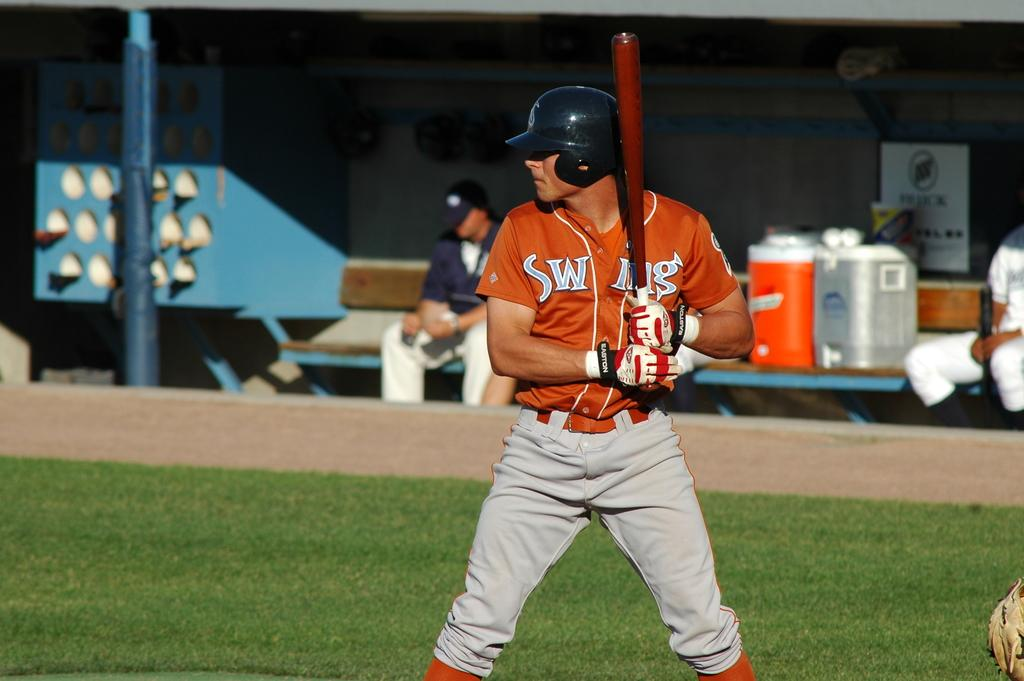<image>
Present a compact description of the photo's key features. A baseball player wearing an orange jersey with the name Swing is at bat. 